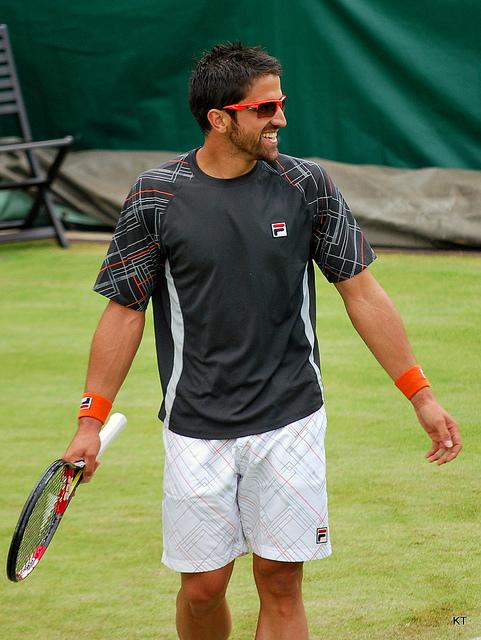What game is he playing?
Keep it brief. Tennis. How many people in the picture?
Keep it brief. 1. What is on the closest man's chin?
Concise answer only. Hair. What color are his glasses?
Answer briefly. Red. Is the man smiling?
Short answer required. Yes. What is around his head?
Answer briefly. Sunglasses. How many men are there?
Concise answer only. 1. What type of hairstyle is this person's hair in?
Quick response, please. Short. 